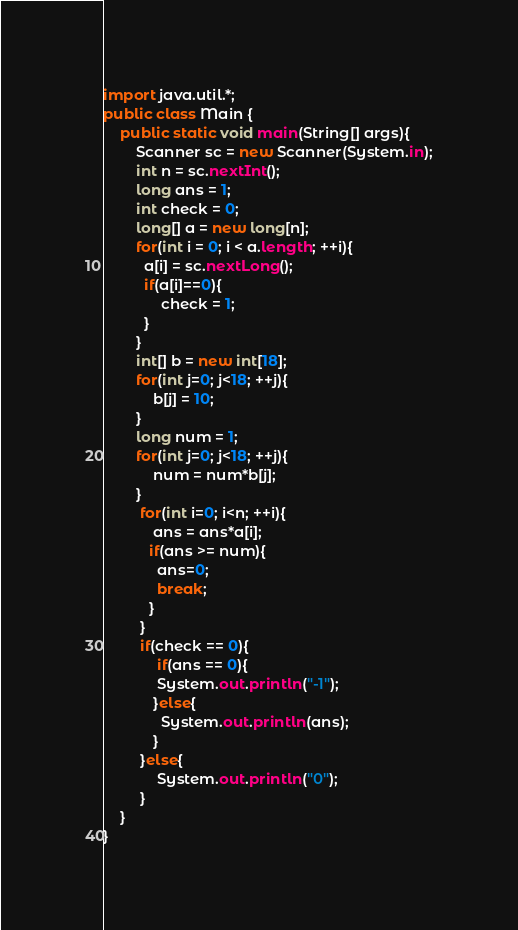Convert code to text. <code><loc_0><loc_0><loc_500><loc_500><_Java_>import java.util.*;
public class Main {
	public static void main(String[] args){
		Scanner sc = new Scanner(System.in);
		int n = sc.nextInt();
		long ans = 1;
		int check = 0;
		long[] a = new long[n];
		for(int i = 0; i < a.length; ++i){
          a[i] = sc.nextLong();
          if(a[i]==0){
              check = 1;
          }
        }
        int[] b = new int[18];
        for(int j=0; j<18; ++j){
            b[j] = 10;
        }
        long num = 1;
        for(int j=0; j<18; ++j){
            num = num*b[j];
        }
         for(int i=0; i<n; ++i){
            ans = ans*a[i];
           if(ans >= num){
             ans=0;
             break;
           }
         }
         if(check == 0){
             if(ans == 0){
             System.out.println("-1");
            }else{
              System.out.println(ans);
            }
         }else{
             System.out.println("0");
         }
	}
}
</code> 